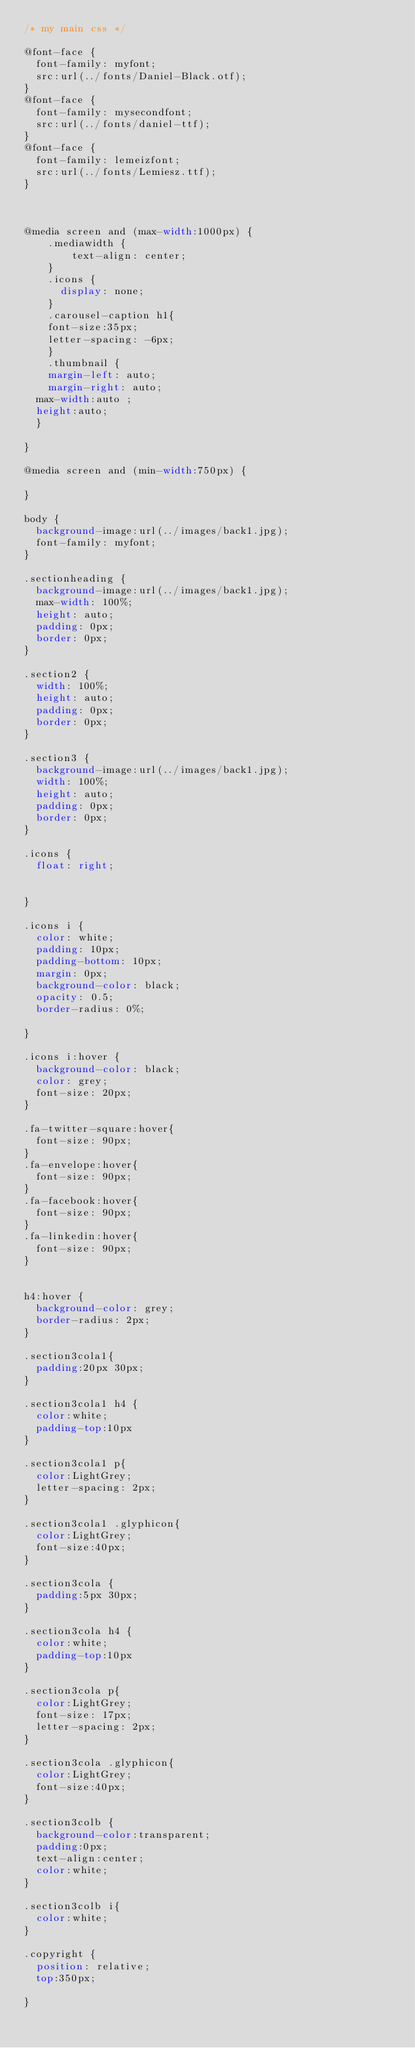Convert code to text. <code><loc_0><loc_0><loc_500><loc_500><_CSS_>/* my main css */

@font-face {
	font-family: myfont;
	src:url(../fonts/Daniel-Black.otf);
}
@font-face {
	font-family: mysecondfont;
	src:url(../fonts/daniel-ttf);
}
@font-face {
	font-family: lemeizfont;
	src:url(../fonts/Lemiesz.ttf);
}

 

@media screen and (max-width:1000px) {
    .mediawidth {
        text-align: center;
    }
    .icons {
    	display: none;
    }
    .carousel-caption h1{
		font-size:35px;
		letter-spacing: -6px;
    }
    .thumbnail {
    margin-left: auto;
    margin-right: auto;
	max-width:auto ;
	height:auto;
	}

}

@media screen and (min-width:750px) {
    
}

body {
	background-image:url(../images/back1.jpg);
	font-family: myfont;
}

.sectionheading {
	background-image:url(../images/back1.jpg);
	max-width: 100%;
	height: auto;
	padding: 0px;
	border: 0px;
}

.section2 {
	width: 100%;
	height: auto;
	padding: 0px;
	border: 0px;
}

.section3 {
	background-image:url(../images/back1.jpg);
	width: 100%;
	height: auto;
	padding: 0px;
	border: 0px;
}

.icons {
	float: right;
	
	
}

.icons i {
	color: white;
	padding: 10px;
	padding-bottom: 10px;
	margin: 0px;
	background-color: black;
	opacity: 0.5;
	border-radius: 0%;

} 

.icons i:hover {
	background-color: black;
	color: grey;
	font-size: 20px;
}

.fa-twitter-square:hover{
	font-size: 90px;
}
.fa-envelope:hover{
	font-size: 90px;
}
.fa-facebook:hover{
	font-size: 90px;
}
.fa-linkedin:hover{
	font-size: 90px;
}	


h4:hover {
	background-color: grey;
	border-radius: 2px;
} 

.section3cola1{
	padding:20px 30px;
}

.section3cola1 h4 {
	color:white;
	padding-top:10px
}

.section3cola1 p{
	color:LightGrey;
	letter-spacing: 2px;
}

.section3cola1 .glyphicon{
	color:LightGrey;
	font-size:40px;
}

.section3cola {
	padding:5px 30px;
}

.section3cola h4 {
	color:white;
	padding-top:10px
}

.section3cola p{
	color:LightGrey;
	font-size: 17px;
	letter-spacing: 2px;
}

.section3cola .glyphicon{
	color:LightGrey;
	font-size:40px;
}

.section3colb {
	background-color:transparent;
	padding:0px;
	text-align:center;
	color:white;
}

.section3colb i{
	color:white;	
}

.copyright {
	position: relative;
	top:350px;
	 
}</code> 